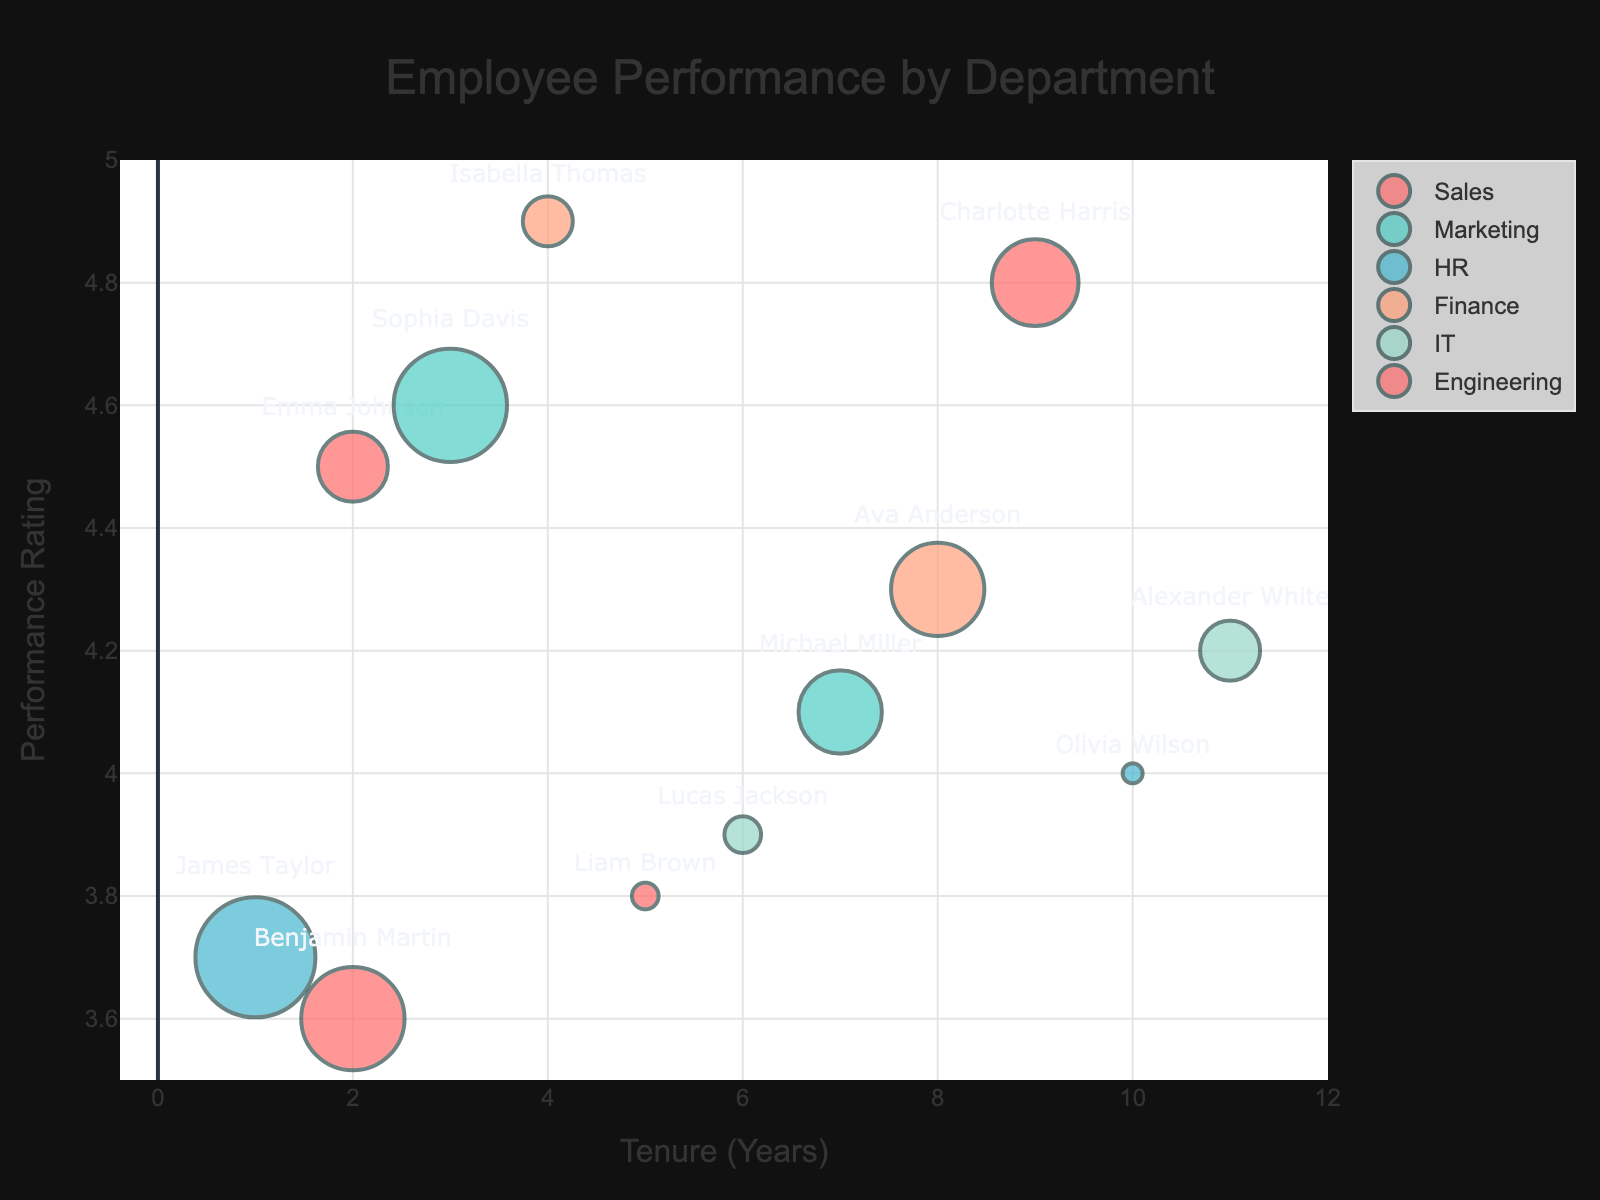What is the title of the bubble chart? Look at the top of the chart where the title is displayed prominently.
Answer: Employee Performance by Department What is the range of performance ratings on the y-axis? Observe the y-axis labels, which indicate the range.
Answer: 3.5 to 5 Which department has the employee with the highest performance rating? Find the highest point on the y-axis and observe its corresponding department.
Answer: Finance Which department has the employee with the longest tenure? Look for the data point farthest to the right on the x-axis and identify its department.
Answer: IT How many data points are there in the chart for the Sales department? Count the number of bubbles labeled as "Sales".
Answer: 2 What is the tenure and performance rating of the employee with the highest training hours? Identify the largest bubble and read its x and y coordinates. This bubble corresponds to the highest training hours.
Answer: James Taylor (1 year tenure, 3.7 rating) Which department has the smallest average performance rating? Identify and average the performance ratings of each department's employees, and compare these averages.
Answer: Sales What is the average tenure of employees in the Engineering department? Sum the tenures of employees in the Engineering department and divide by the number of employees in that department.
Answer: (9 + 2) / 2 = 5.5 Are there any departments where all employees have a performance rating above 4? Examine each department's employees' performance ratings and check if any department has all ratings above 4.
Answer: Marketing, Finance, Engineering Which employees in the HR department have higher performance ratings than the average performance rating of the department? Calculate the average performance rating of the HR department and compare each employee's rating to this average.
Answer: Olivia Wilson 